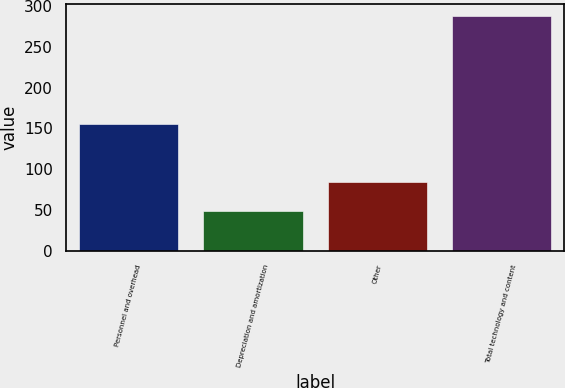Convert chart to OTSL. <chart><loc_0><loc_0><loc_500><loc_500><bar_chart><fcel>Personnel and overhead<fcel>Depreciation and amortization<fcel>Other<fcel>Total technology and content<nl><fcel>156<fcel>48<fcel>84<fcel>288<nl></chart> 